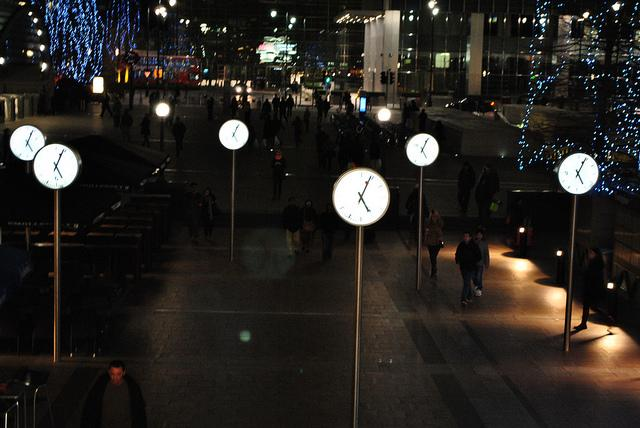Why are there blue lights on the trees? Please explain your reasoning. for holiday. There are blue lights on the trees for decoration in celebration of a holiday. 